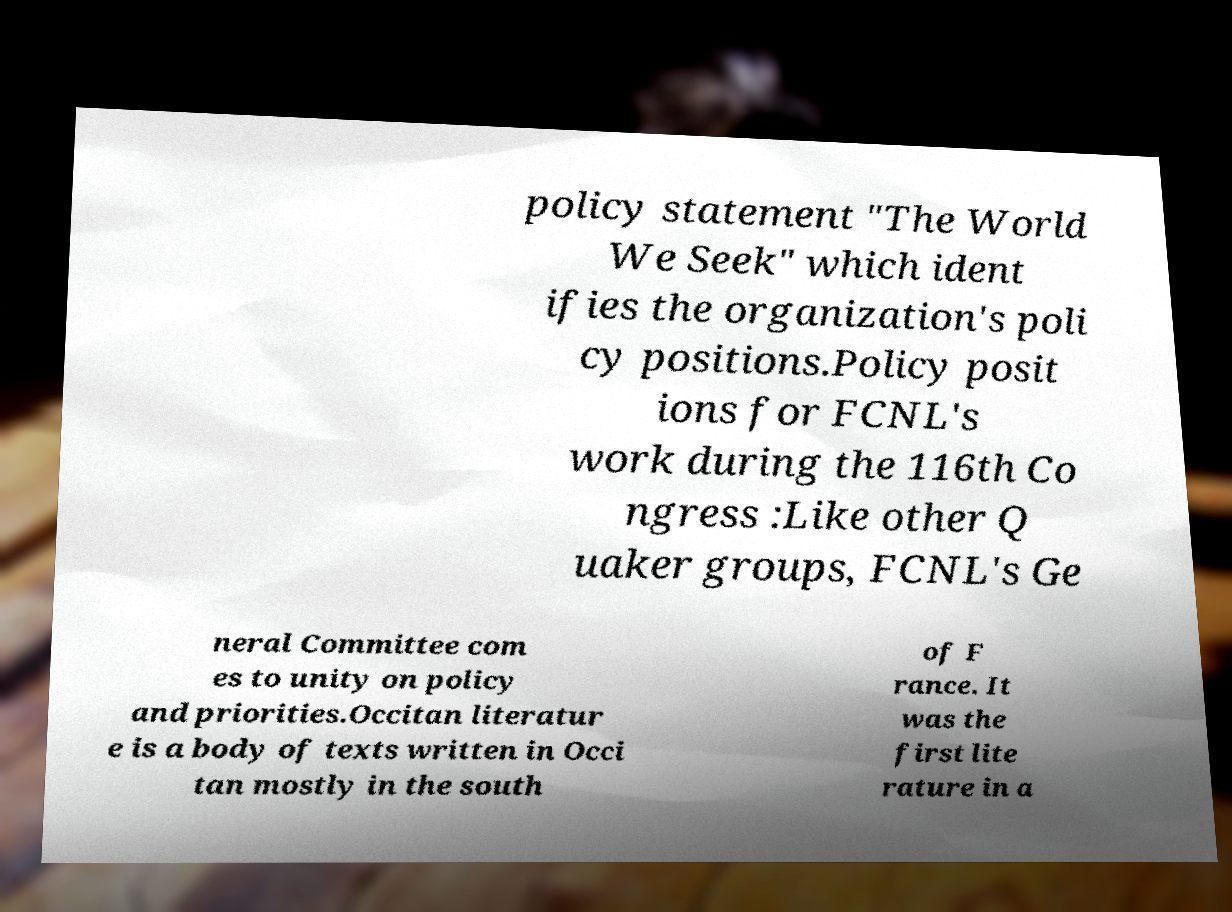What messages or text are displayed in this image? I need them in a readable, typed format. policy statement "The World We Seek" which ident ifies the organization's poli cy positions.Policy posit ions for FCNL's work during the 116th Co ngress :Like other Q uaker groups, FCNL's Ge neral Committee com es to unity on policy and priorities.Occitan literatur e is a body of texts written in Occi tan mostly in the south of F rance. It was the first lite rature in a 